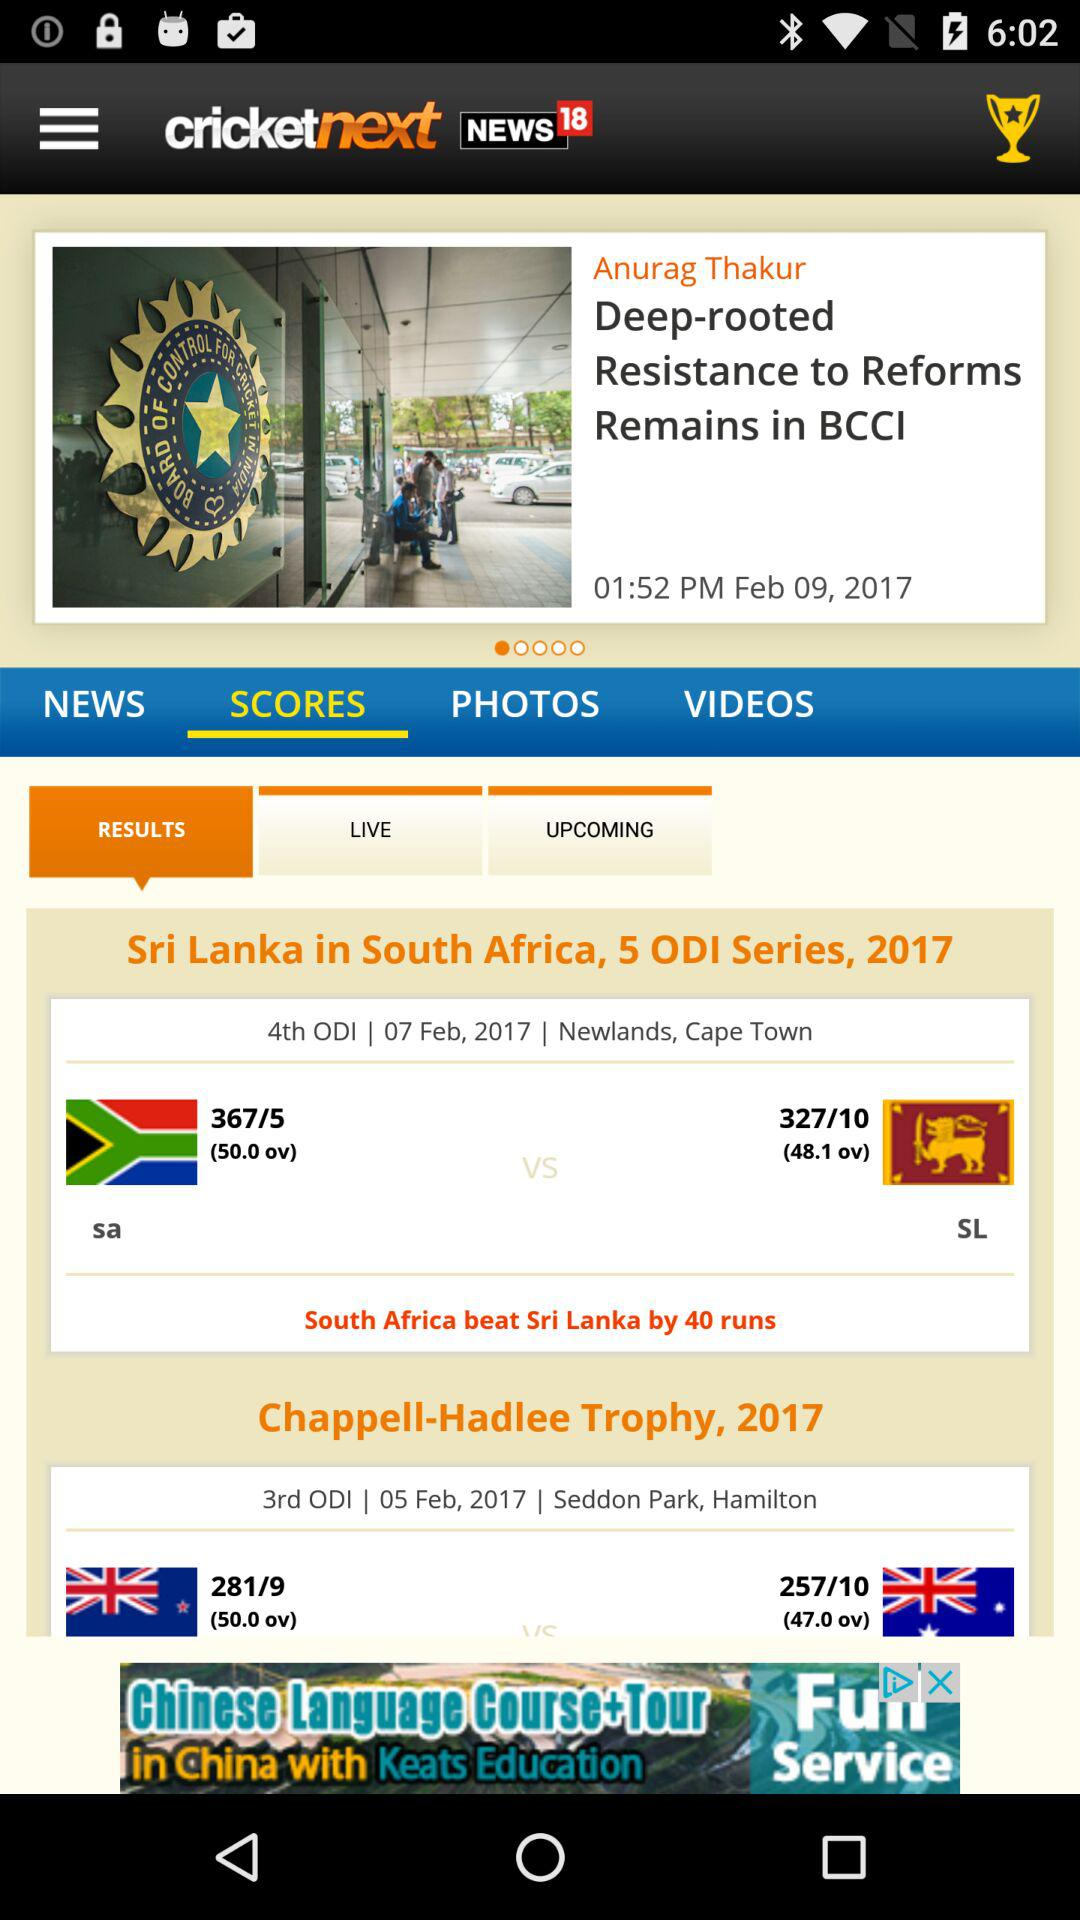How many runs more did South Africa score than Sri Lanka in the 4th ODI?
Answer the question using a single word or phrase. 40 